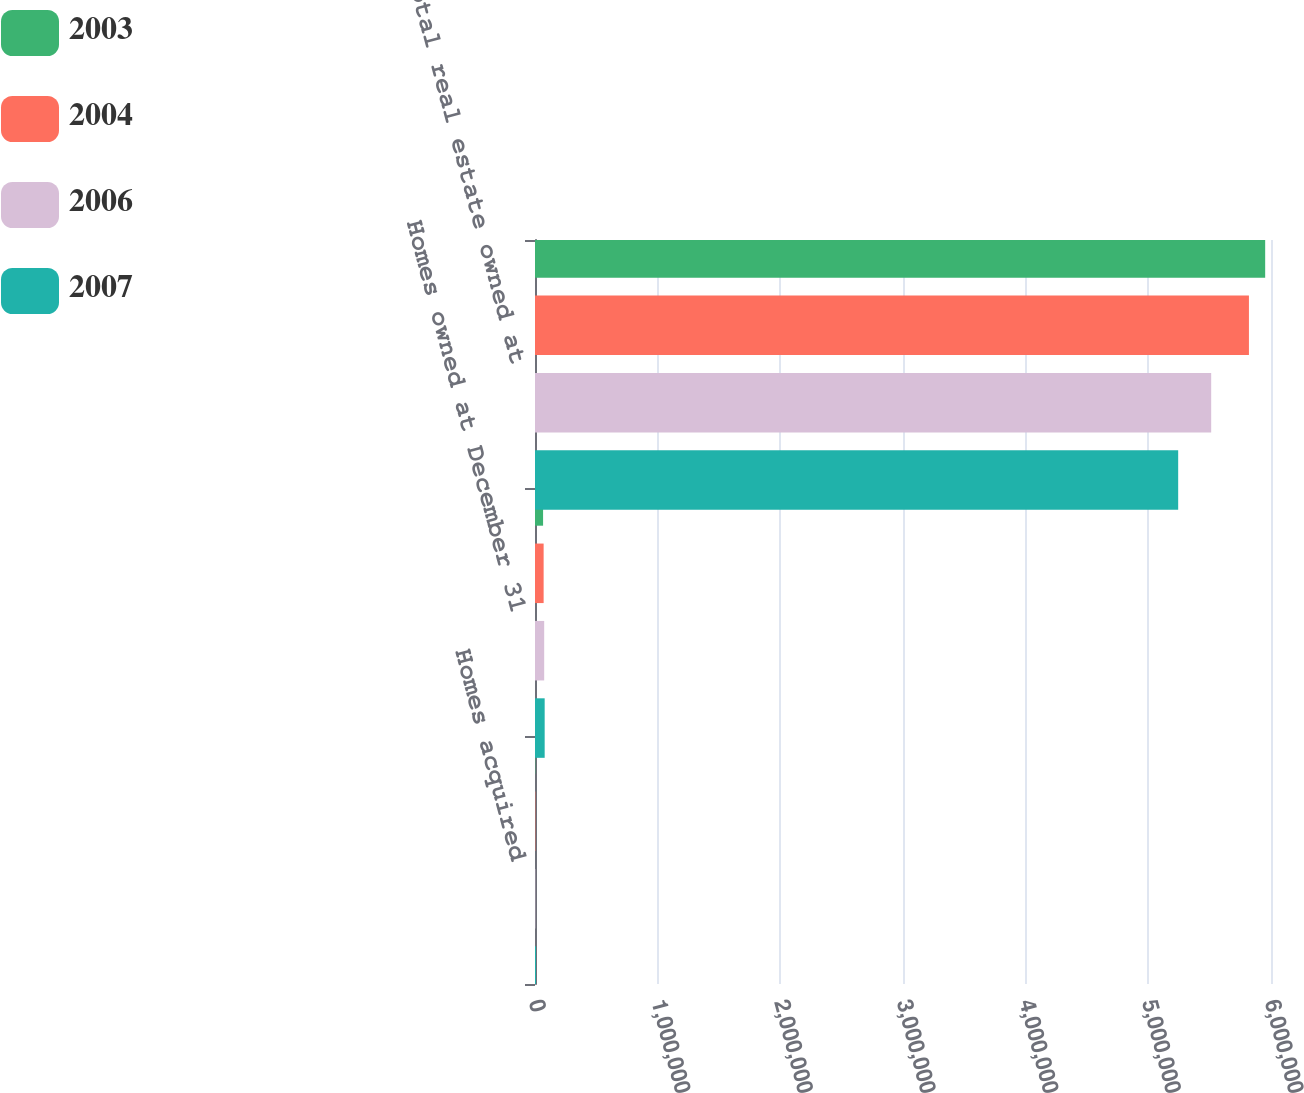Convert chart to OTSL. <chart><loc_0><loc_0><loc_500><loc_500><stacked_bar_chart><ecel><fcel>Homes acquired<fcel>Homes owned at December 31<fcel>Total real estate owned at<nl><fcel>2003<fcel>2671<fcel>65867<fcel>5.95254e+06<nl><fcel>2004<fcel>2763<fcel>70339<fcel>5.82012e+06<nl><fcel>2006<fcel>2561<fcel>74875<fcel>5.51242e+06<nl><fcel>2007<fcel>8060<fcel>78855<fcel>5.2433e+06<nl></chart> 